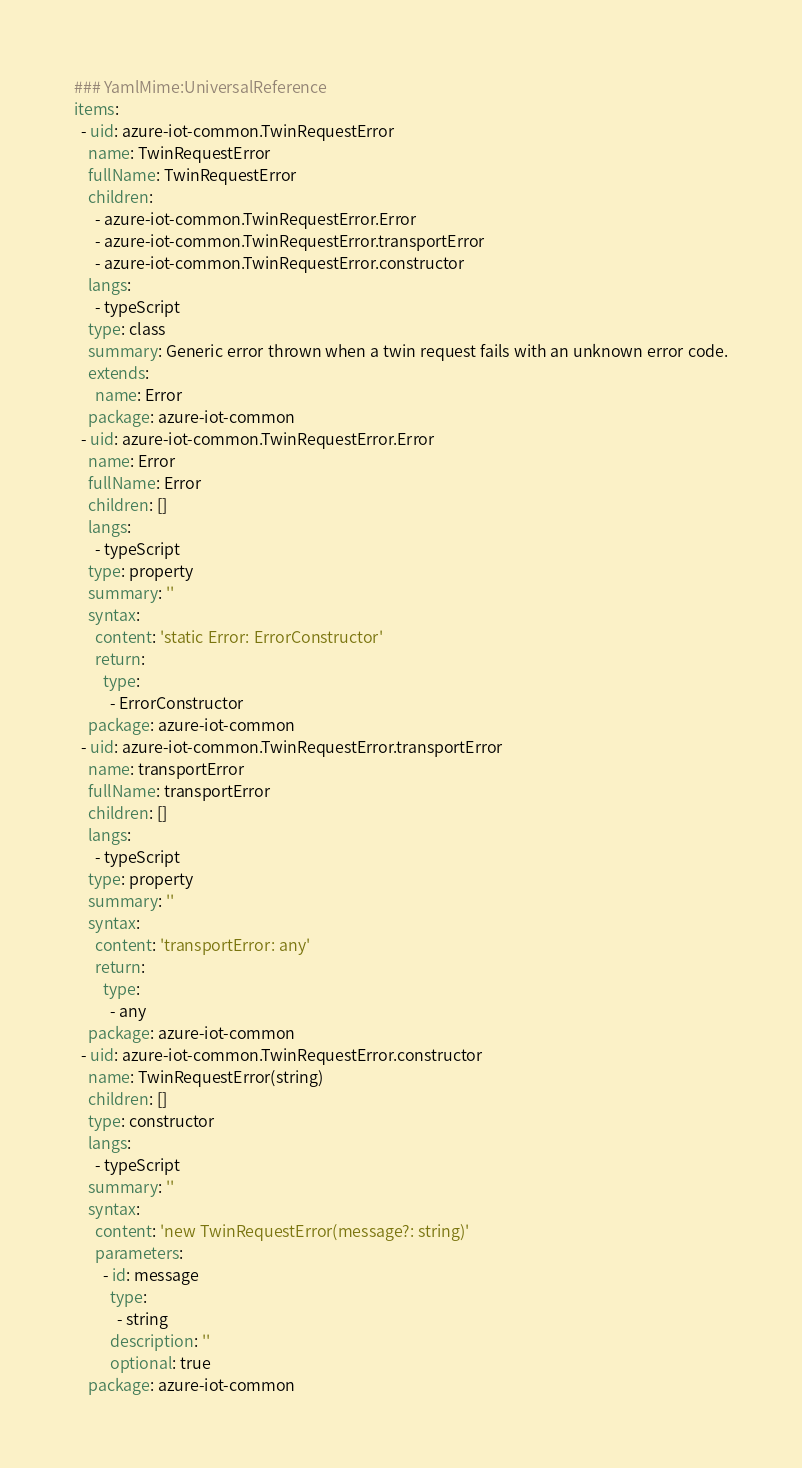<code> <loc_0><loc_0><loc_500><loc_500><_YAML_>### YamlMime:UniversalReference
items:
  - uid: azure-iot-common.TwinRequestError
    name: TwinRequestError
    fullName: TwinRequestError
    children:
      - azure-iot-common.TwinRequestError.Error
      - azure-iot-common.TwinRequestError.transportError
      - azure-iot-common.TwinRequestError.constructor
    langs:
      - typeScript
    type: class
    summary: Generic error thrown when a twin request fails with an unknown error code.
    extends:
      name: Error
    package: azure-iot-common
  - uid: azure-iot-common.TwinRequestError.Error
    name: Error
    fullName: Error
    children: []
    langs:
      - typeScript
    type: property
    summary: ''
    syntax:
      content: 'static Error: ErrorConstructor'
      return:
        type:
          - ErrorConstructor
    package: azure-iot-common
  - uid: azure-iot-common.TwinRequestError.transportError
    name: transportError
    fullName: transportError
    children: []
    langs:
      - typeScript
    type: property
    summary: ''
    syntax:
      content: 'transportError: any'
      return:
        type:
          - any
    package: azure-iot-common
  - uid: azure-iot-common.TwinRequestError.constructor
    name: TwinRequestError(string)
    children: []
    type: constructor
    langs:
      - typeScript
    summary: ''
    syntax:
      content: 'new TwinRequestError(message?: string)'
      parameters:
        - id: message
          type:
            - string
          description: ''
          optional: true
    package: azure-iot-common
</code> 